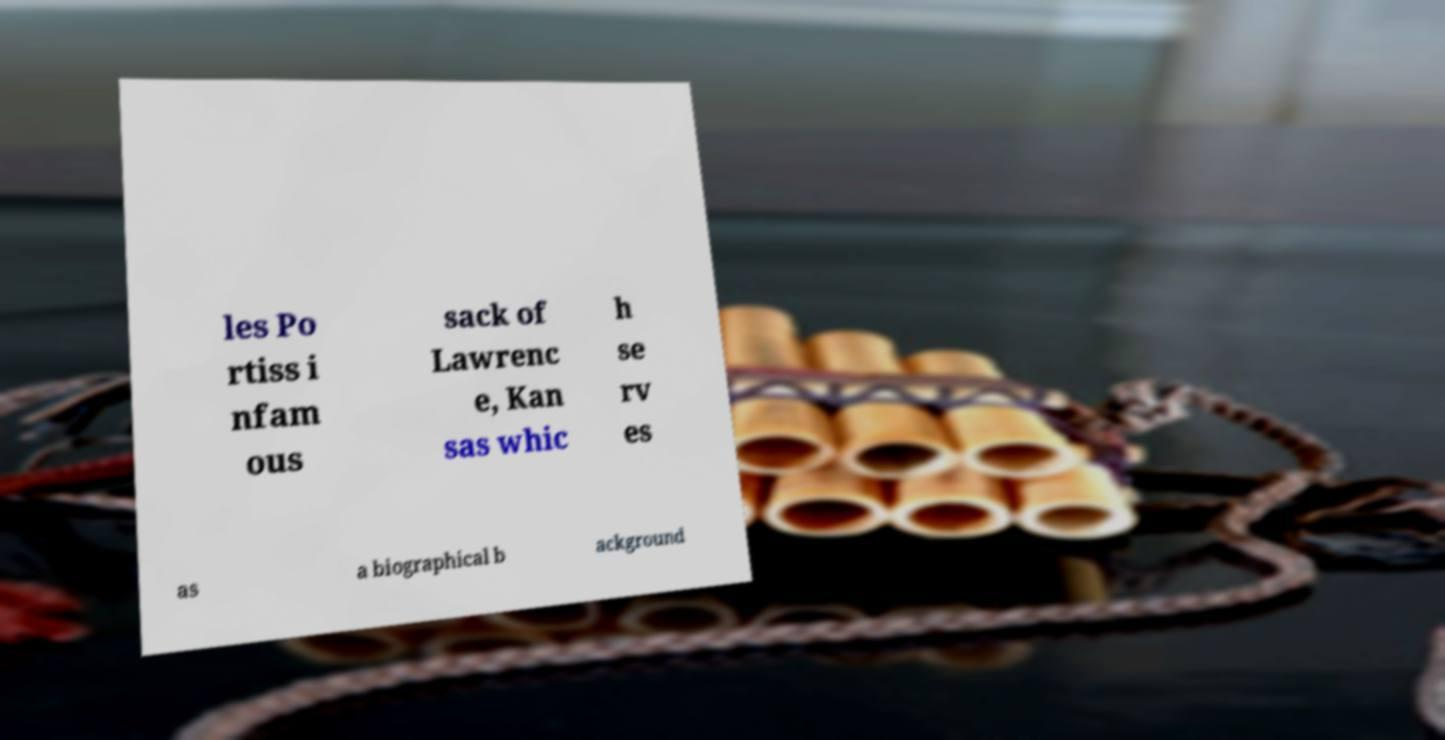Please identify and transcribe the text found in this image. les Po rtiss i nfam ous sack of Lawrenc e, Kan sas whic h se rv es as a biographical b ackground 